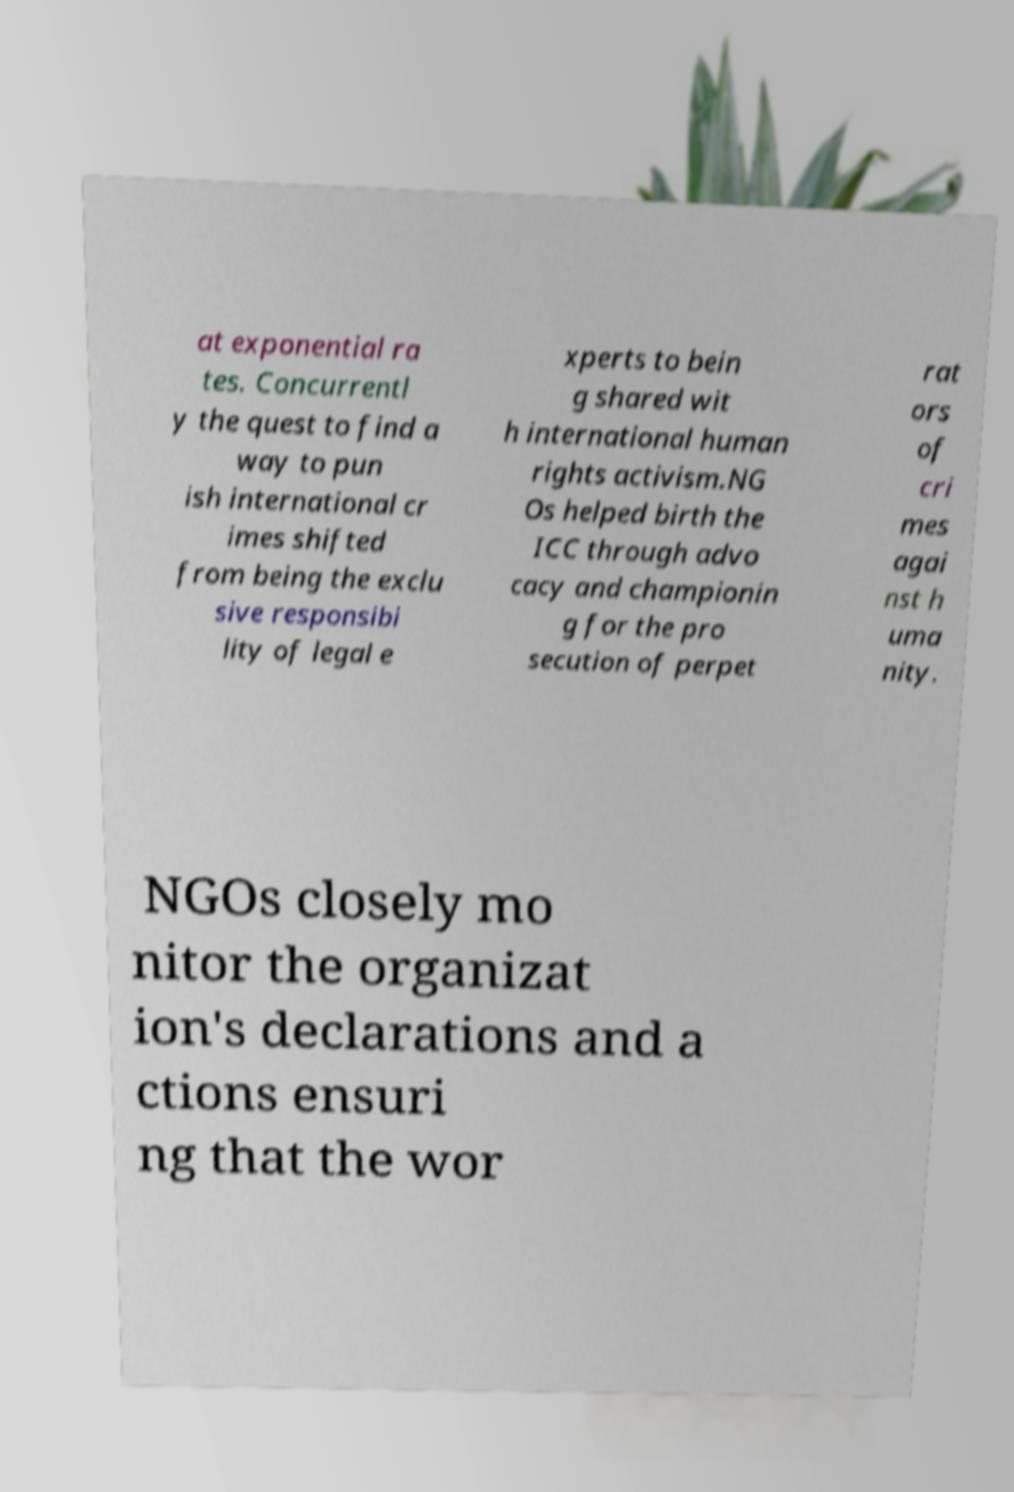I need the written content from this picture converted into text. Can you do that? at exponential ra tes. Concurrentl y the quest to find a way to pun ish international cr imes shifted from being the exclu sive responsibi lity of legal e xperts to bein g shared wit h international human rights activism.NG Os helped birth the ICC through advo cacy and championin g for the pro secution of perpet rat ors of cri mes agai nst h uma nity. NGOs closely mo nitor the organizat ion's declarations and a ctions ensuri ng that the wor 